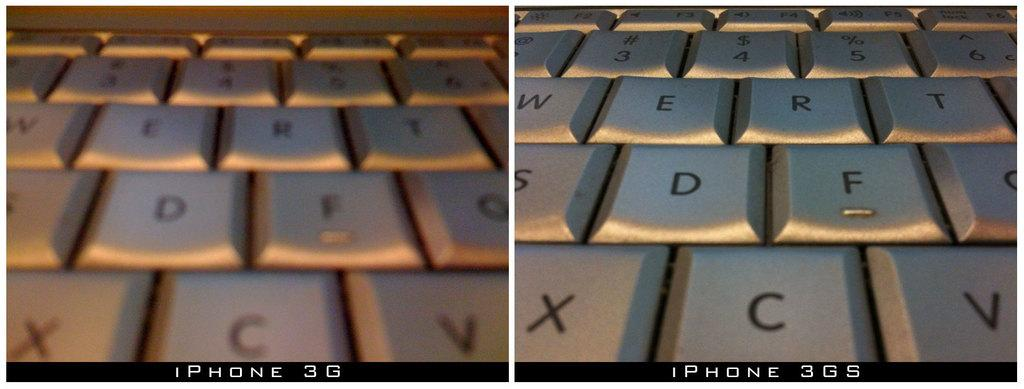<image>
Present a compact description of the photo's key features. Two close ups of a keyboard, with XCV on the bottom row of the right one 